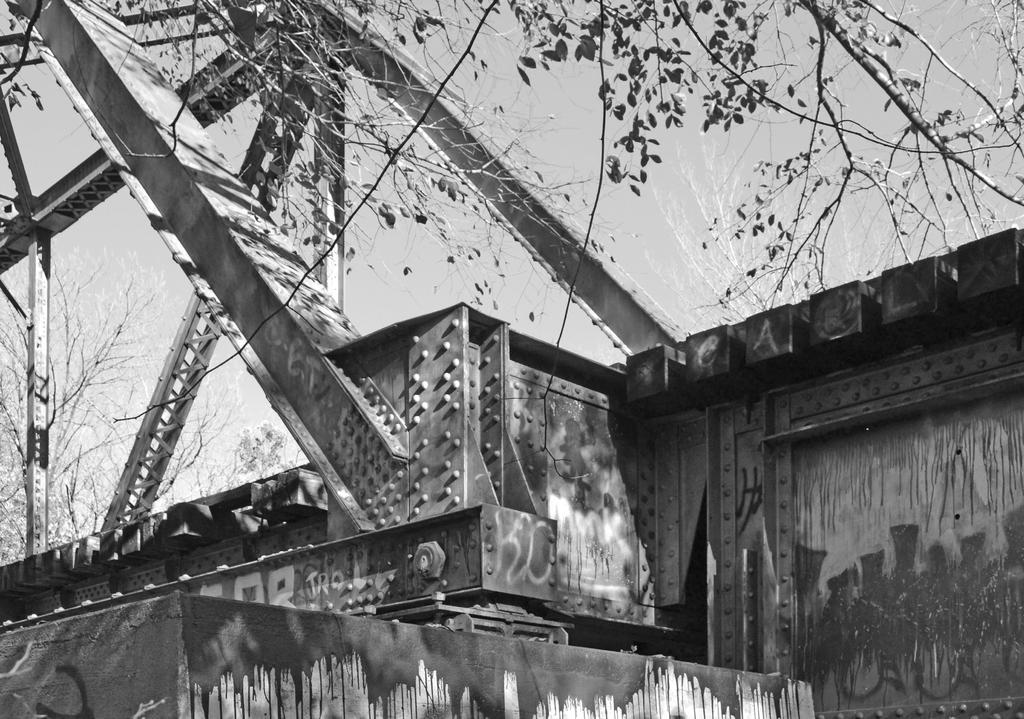What type of vegetation can be seen in the image? There are trees in the image. What object with metal rods is visible in the image? There is an object with metal rods in the image. What can be seen in the background of the image? The sky is visible in the background of the image. What is the color scheme of the image? The image is black and white in color. Can you hear the turkey laughing in the image? There is no turkey or laughter present in the image, as it is a black and white image featuring trees and an object with metal rods. 